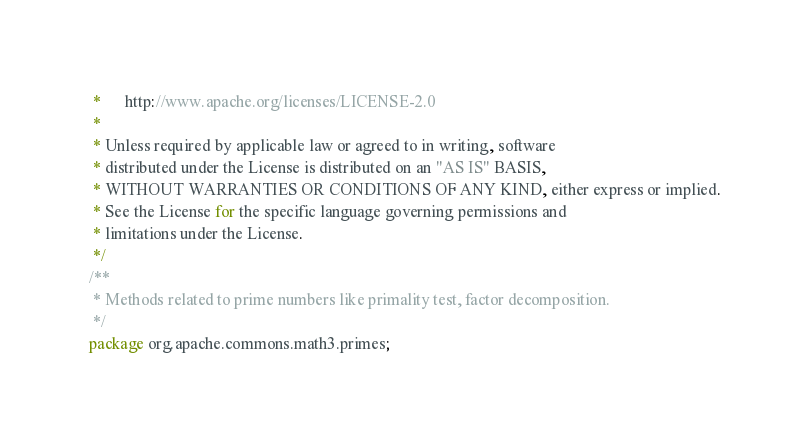Convert code to text. <code><loc_0><loc_0><loc_500><loc_500><_Java_> *      http://www.apache.org/licenses/LICENSE-2.0
 *
 * Unless required by applicable law or agreed to in writing, software
 * distributed under the License is distributed on an "AS IS" BASIS,
 * WITHOUT WARRANTIES OR CONDITIONS OF ANY KIND, either express or implied.
 * See the License for the specific language governing permissions and
 * limitations under the License.
 */
/**
 * Methods related to prime numbers like primality test, factor decomposition.
 */
package org.apache.commons.math3.primes;
</code> 